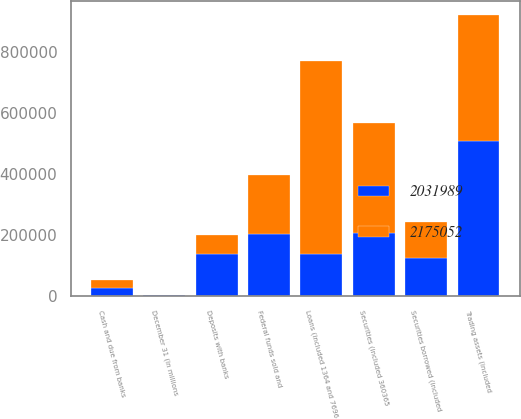Convert chart to OTSL. <chart><loc_0><loc_0><loc_500><loc_500><stacked_bar_chart><ecel><fcel>December 31 (in millions<fcel>Cash and due from banks<fcel>Deposits with banks<fcel>Federal funds sold and<fcel>Securities borrowed (included<fcel>Trading assets (included<fcel>Securities (included 360365<fcel>Loans (included 1364 and 7696<nl><fcel>2.17505e+06<fcel>2009<fcel>26206<fcel>63230<fcel>195404<fcel>119630<fcel>411128<fcel>360390<fcel>633458<nl><fcel>2.03199e+06<fcel>2008<fcel>26895<fcel>138139<fcel>203115<fcel>124000<fcel>509983<fcel>205943<fcel>138139<nl></chart> 